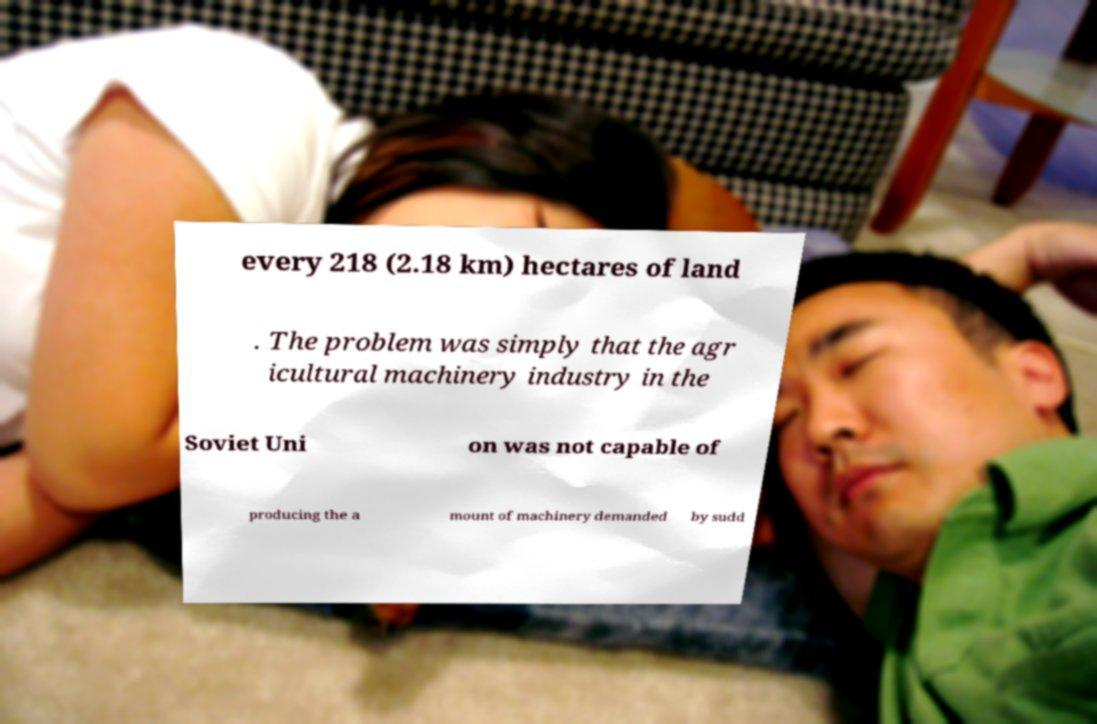Can you read and provide the text displayed in the image?This photo seems to have some interesting text. Can you extract and type it out for me? every 218 (2.18 km) hectares of land . The problem was simply that the agr icultural machinery industry in the Soviet Uni on was not capable of producing the a mount of machinery demanded by sudd 